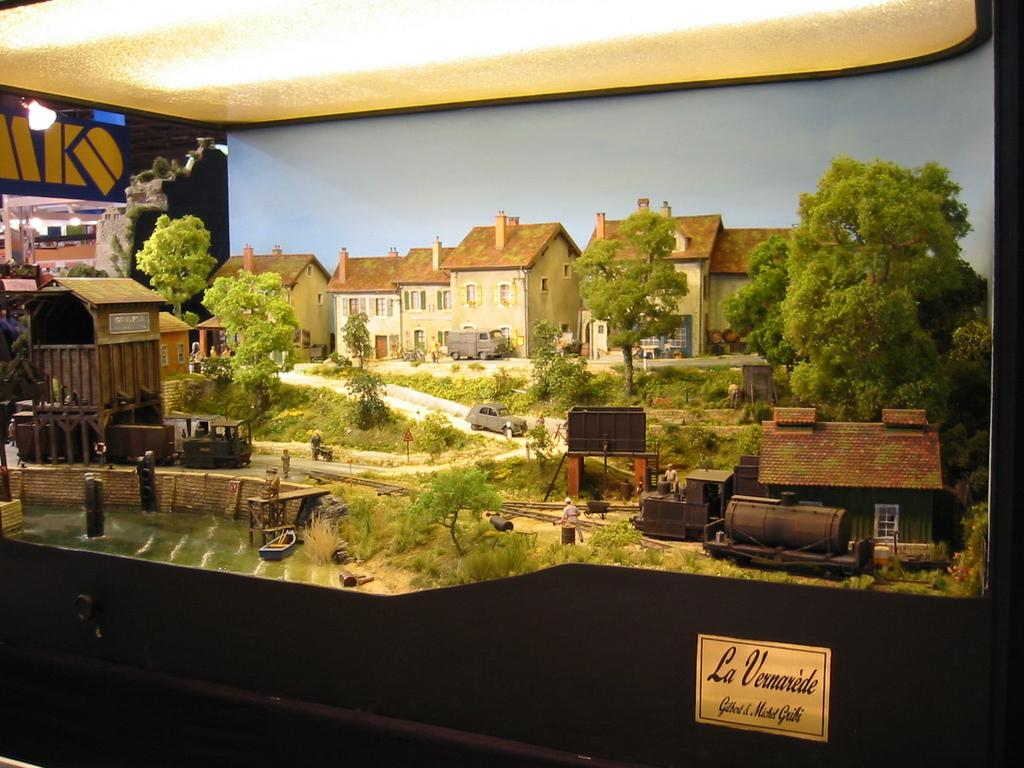<image>
Present a compact description of the photo's key features. A picture of La Vernarede displayed for people to see. 